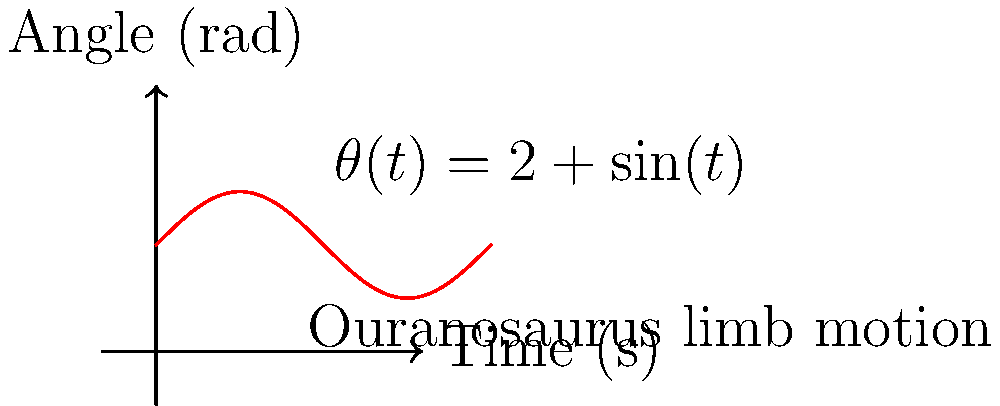The graph shows a simplified model of an Ouranosaurus limb's angular motion. If you were to design a robotic arm to mimic this motion, what would be the maximum angular velocity of the arm in radians per second? To find the maximum angular velocity, we need to follow these steps:

1. The given function for the angle is $\theta(t) = 2 + \sin(t)$

2. The angular velocity is the derivative of the angle with respect to time:
   $\omega(t) = \frac{d\theta}{dt} = \frac{d}{dt}(2 + \sin(t)) = \cos(t)$

3. The maximum value of $\cos(t)$ is 1, which occurs when $t = 0, 2\pi, 4\pi,$ etc.

4. Therefore, the maximum angular velocity is 1 radian per second.

This means that at its fastest point, the robotic arm mimicking the Ouranosaurus limb would need to move at a rate of 1 radian per second to accurately replicate the motion.
Answer: 1 rad/s 